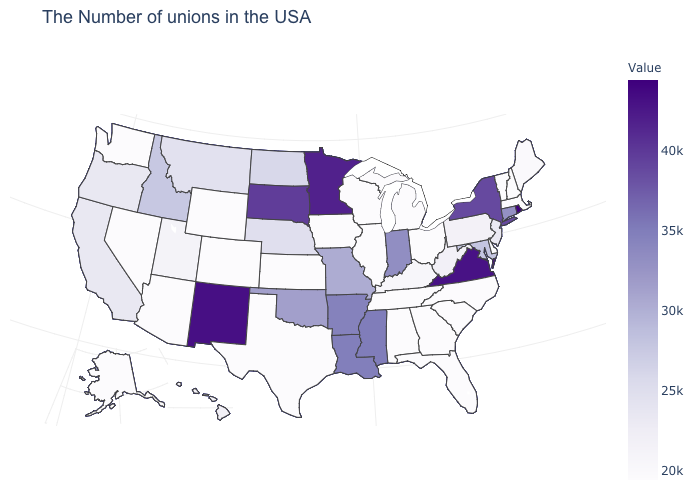Among the states that border South Dakota , does Minnesota have the highest value?
Short answer required. Yes. Is the legend a continuous bar?
Keep it brief. Yes. Does Mississippi have a higher value than Nevada?
Be succinct. Yes. Among the states that border Connecticut , which have the highest value?
Be succinct. Rhode Island. Which states have the lowest value in the MidWest?
Write a very short answer. Ohio, Michigan, Wisconsin, Illinois, Iowa, Kansas. 